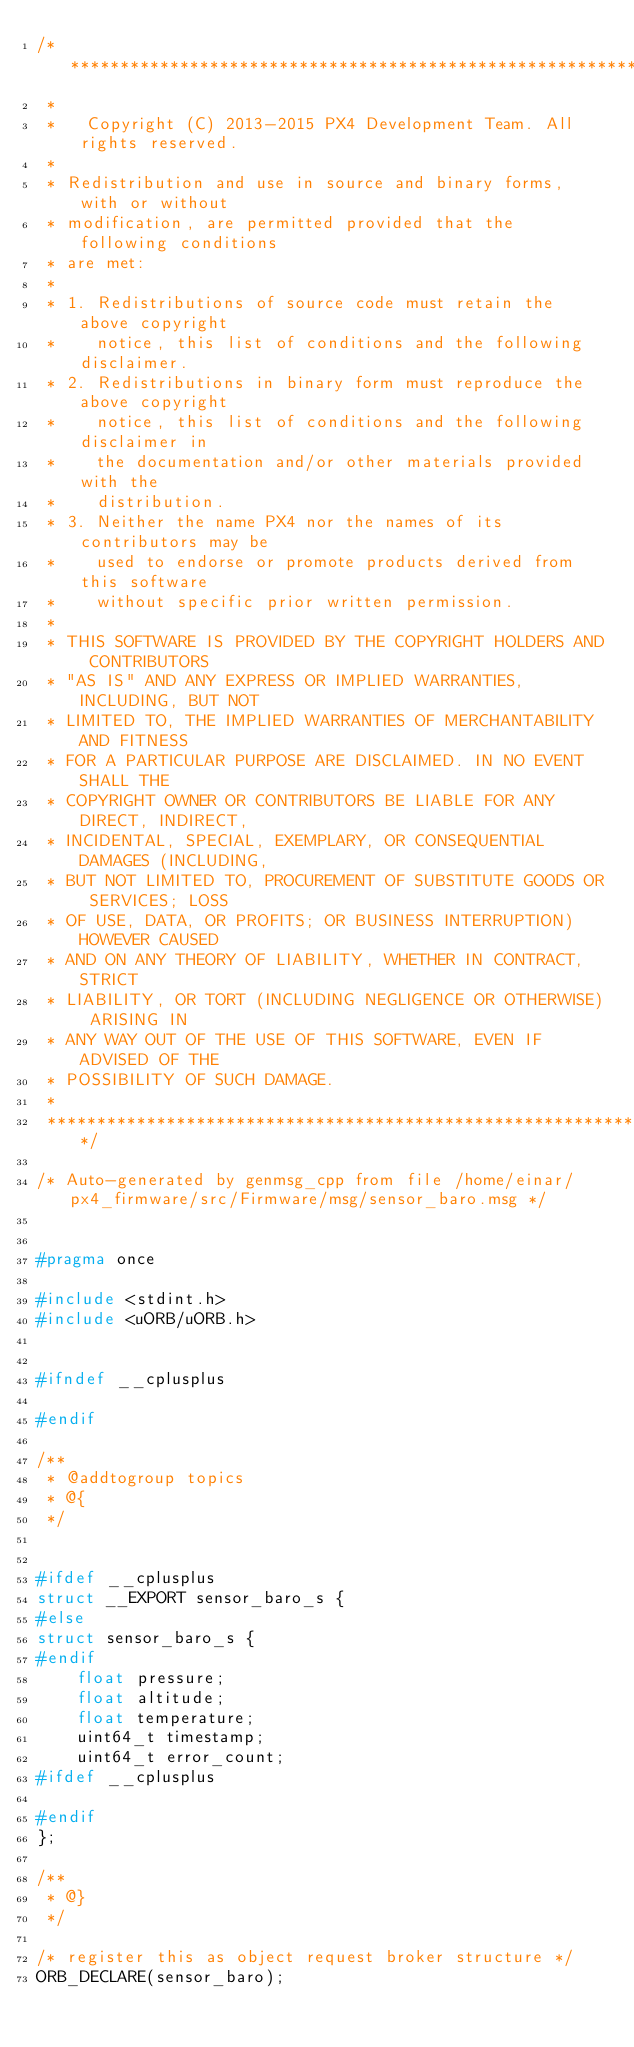Convert code to text. <code><loc_0><loc_0><loc_500><loc_500><_C_>/****************************************************************************
 *
 *   Copyright (C) 2013-2015 PX4 Development Team. All rights reserved.
 *
 * Redistribution and use in source and binary forms, with or without
 * modification, are permitted provided that the following conditions
 * are met:
 *
 * 1. Redistributions of source code must retain the above copyright
 *    notice, this list of conditions and the following disclaimer.
 * 2. Redistributions in binary form must reproduce the above copyright
 *    notice, this list of conditions and the following disclaimer in
 *    the documentation and/or other materials provided with the
 *    distribution.
 * 3. Neither the name PX4 nor the names of its contributors may be
 *    used to endorse or promote products derived from this software
 *    without specific prior written permission.
 *
 * THIS SOFTWARE IS PROVIDED BY THE COPYRIGHT HOLDERS AND CONTRIBUTORS
 * "AS IS" AND ANY EXPRESS OR IMPLIED WARRANTIES, INCLUDING, BUT NOT
 * LIMITED TO, THE IMPLIED WARRANTIES OF MERCHANTABILITY AND FITNESS
 * FOR A PARTICULAR PURPOSE ARE DISCLAIMED. IN NO EVENT SHALL THE
 * COPYRIGHT OWNER OR CONTRIBUTORS BE LIABLE FOR ANY DIRECT, INDIRECT,
 * INCIDENTAL, SPECIAL, EXEMPLARY, OR CONSEQUENTIAL DAMAGES (INCLUDING,
 * BUT NOT LIMITED TO, PROCUREMENT OF SUBSTITUTE GOODS OR SERVICES; LOSS
 * OF USE, DATA, OR PROFITS; OR BUSINESS INTERRUPTION) HOWEVER CAUSED
 * AND ON ANY THEORY OF LIABILITY, WHETHER IN CONTRACT, STRICT
 * LIABILITY, OR TORT (INCLUDING NEGLIGENCE OR OTHERWISE) ARISING IN
 * ANY WAY OUT OF THE USE OF THIS SOFTWARE, EVEN IF ADVISED OF THE
 * POSSIBILITY OF SUCH DAMAGE.
 *
 ****************************************************************************/

/* Auto-generated by genmsg_cpp from file /home/einar/px4_firmware/src/Firmware/msg/sensor_baro.msg */


#pragma once

#include <stdint.h>
#include <uORB/uORB.h>


#ifndef __cplusplus

#endif

/**
 * @addtogroup topics
 * @{
 */


#ifdef __cplusplus
struct __EXPORT sensor_baro_s {
#else
struct sensor_baro_s {
#endif
	float pressure;
	float altitude;
	float temperature;
	uint64_t timestamp;
	uint64_t error_count;
#ifdef __cplusplus

#endif
};

/**
 * @}
 */

/* register this as object request broker structure */
ORB_DECLARE(sensor_baro);
</code> 